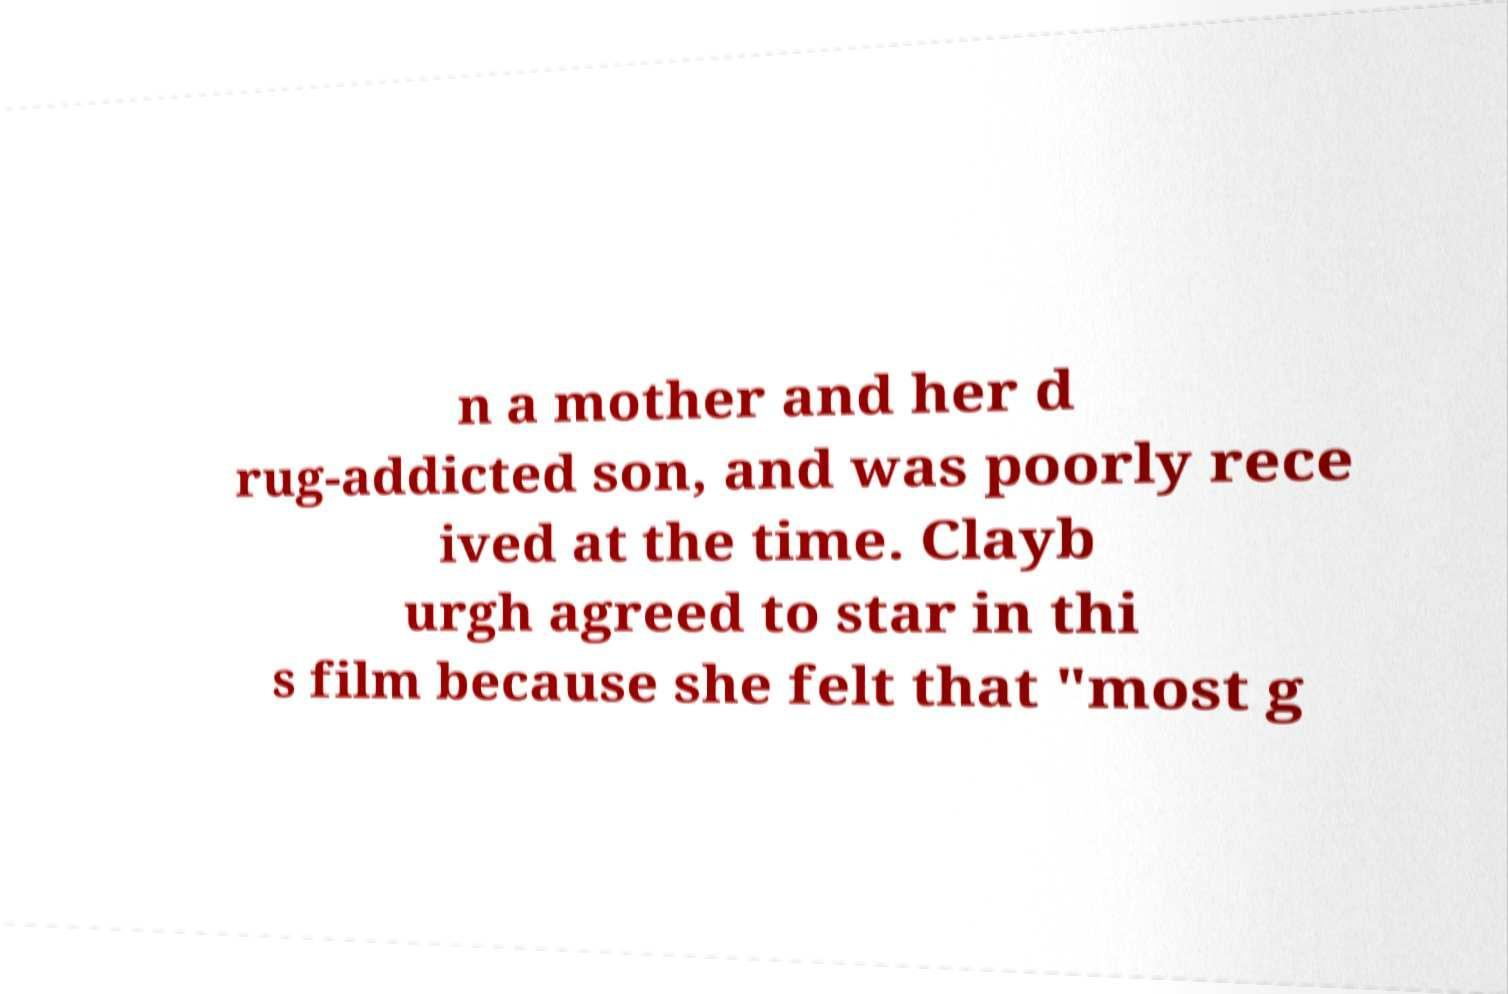Please read and relay the text visible in this image. What does it say? n a mother and her d rug-addicted son, and was poorly rece ived at the time. Clayb urgh agreed to star in thi s film because she felt that "most g 